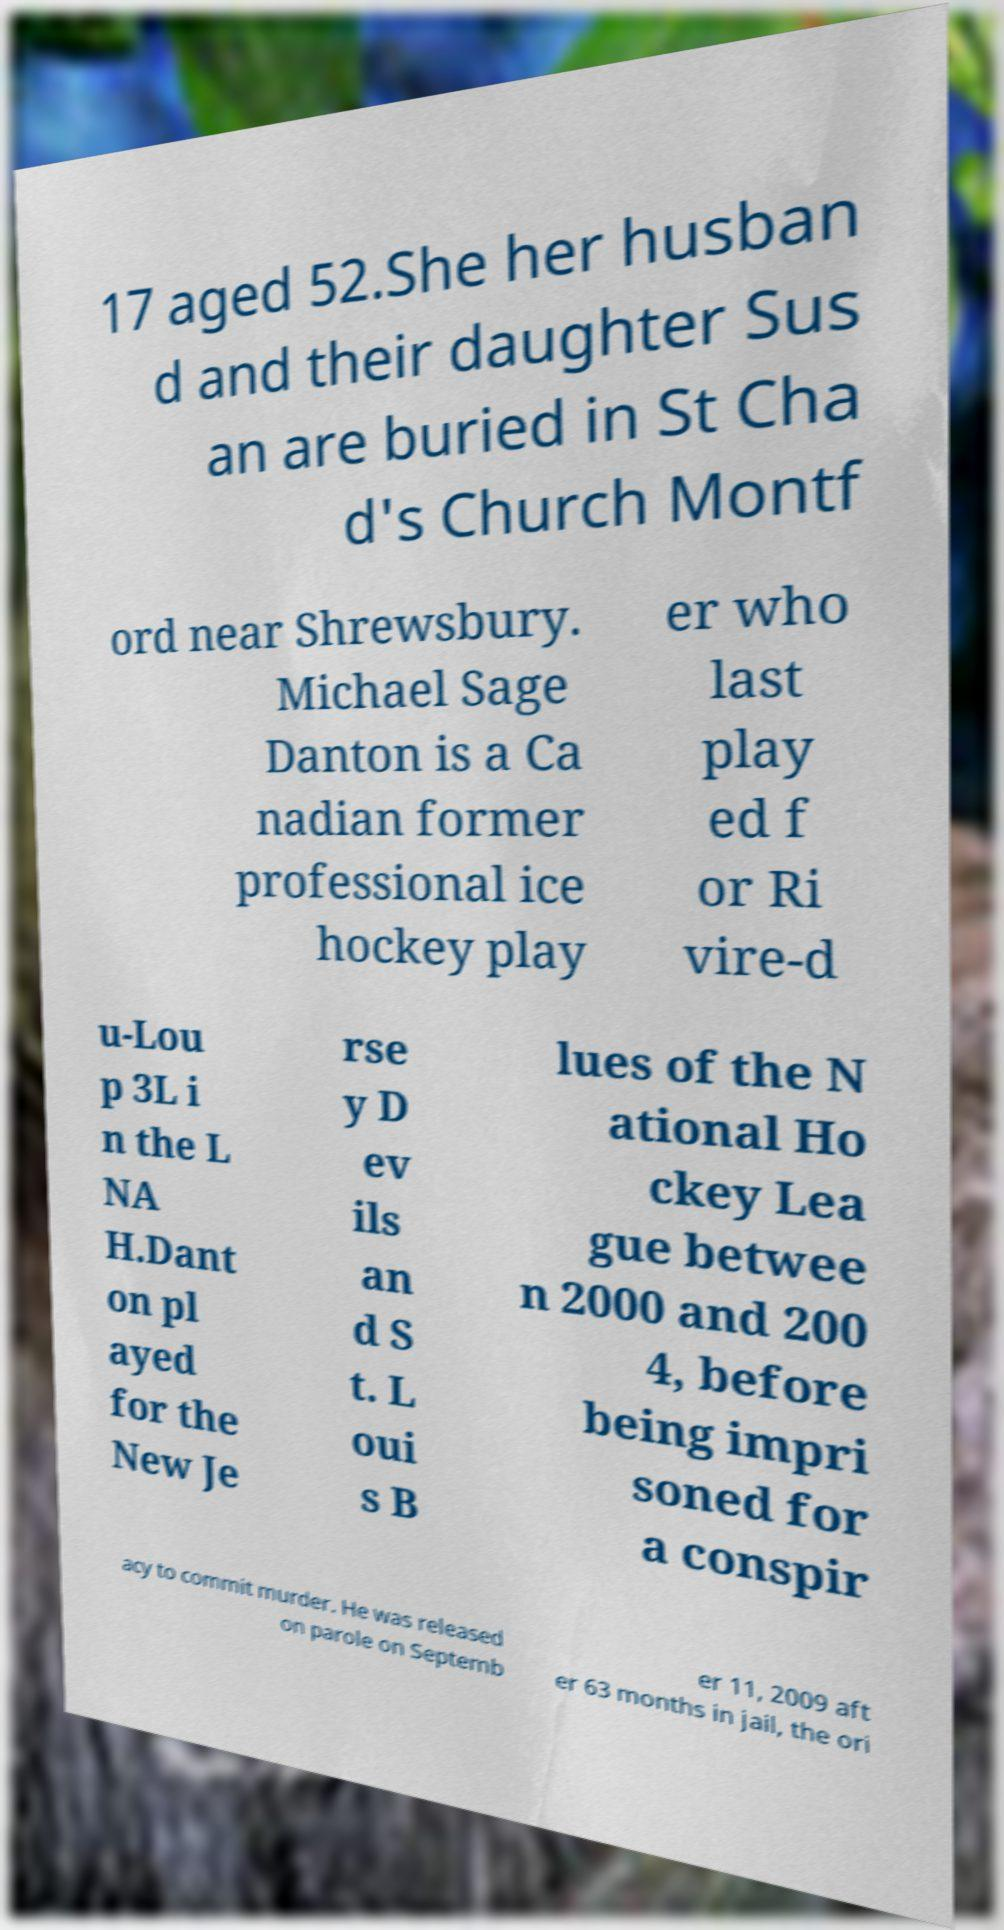There's text embedded in this image that I need extracted. Can you transcribe it verbatim? 17 aged 52.She her husban d and their daughter Sus an are buried in St Cha d's Church Montf ord near Shrewsbury. Michael Sage Danton is a Ca nadian former professional ice hockey play er who last play ed f or Ri vire-d u-Lou p 3L i n the L NA H.Dant on pl ayed for the New Je rse y D ev ils an d S t. L oui s B lues of the N ational Ho ckey Lea gue betwee n 2000 and 200 4, before being impri soned for a conspir acy to commit murder. He was released on parole on Septemb er 11, 2009 aft er 63 months in jail, the ori 